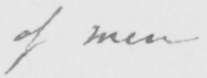Can you read and transcribe this handwriting? of men 